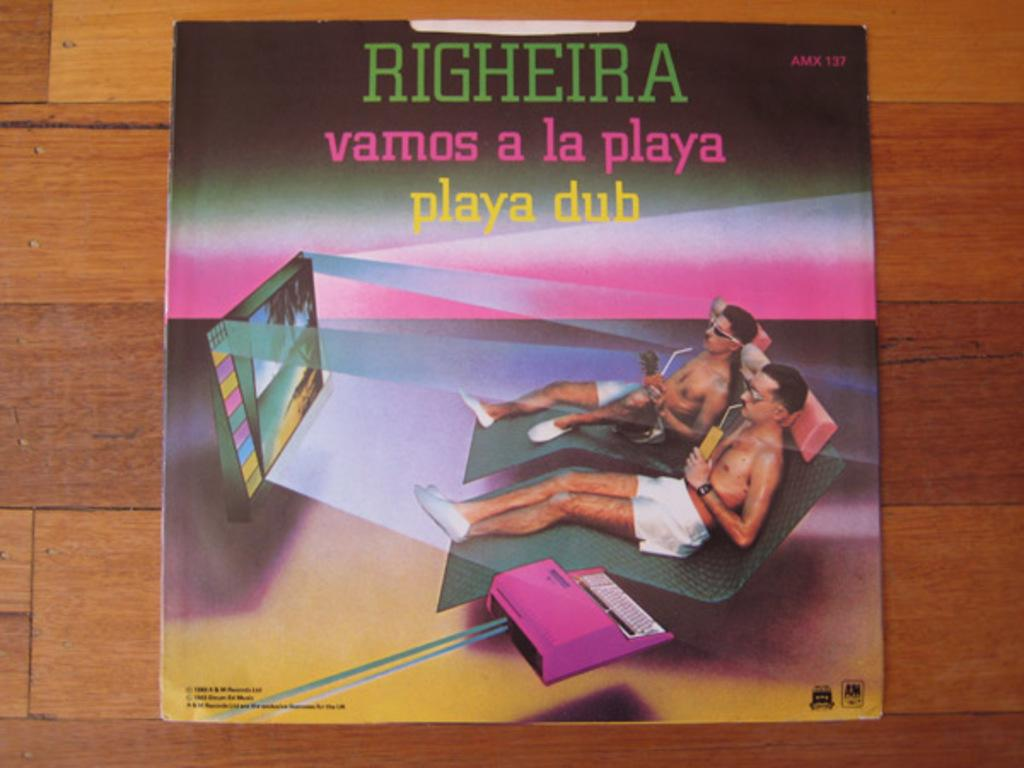<image>
Share a concise interpretation of the image provided. an artists depection of two men relaxing is labeled RIGHEIRA 